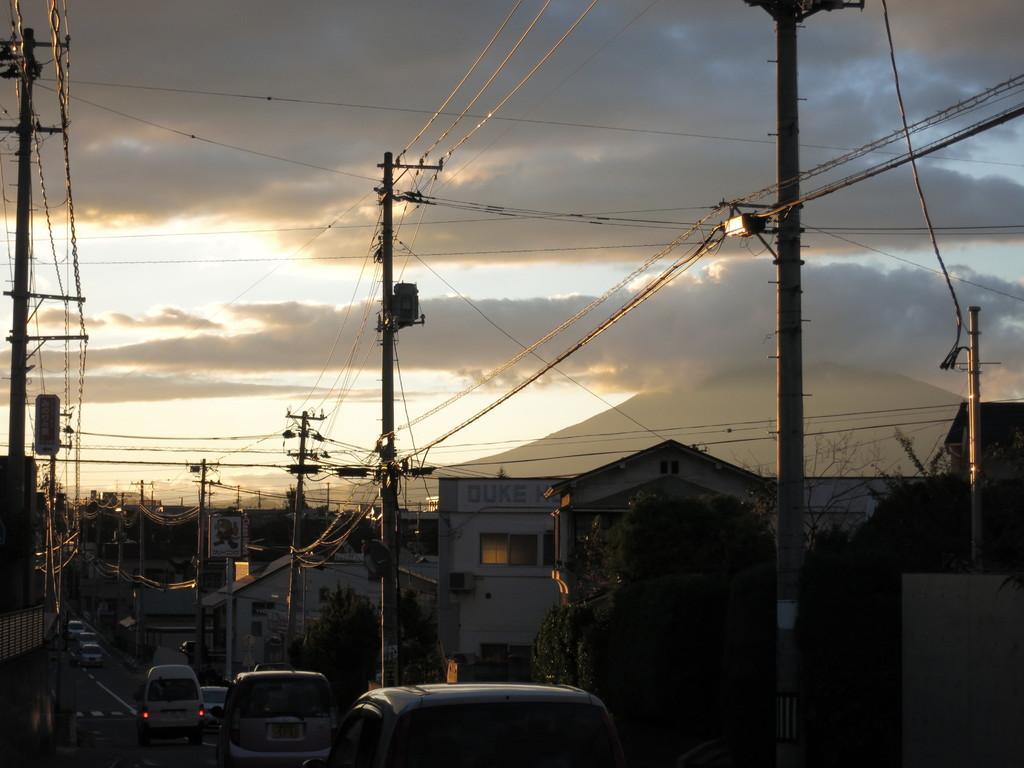Describe this image in one or two sentences. In this picture there are cars at the bottom side of the image and there are houses, trees, and pole in the center of the image and their wires at the top side of the image. 